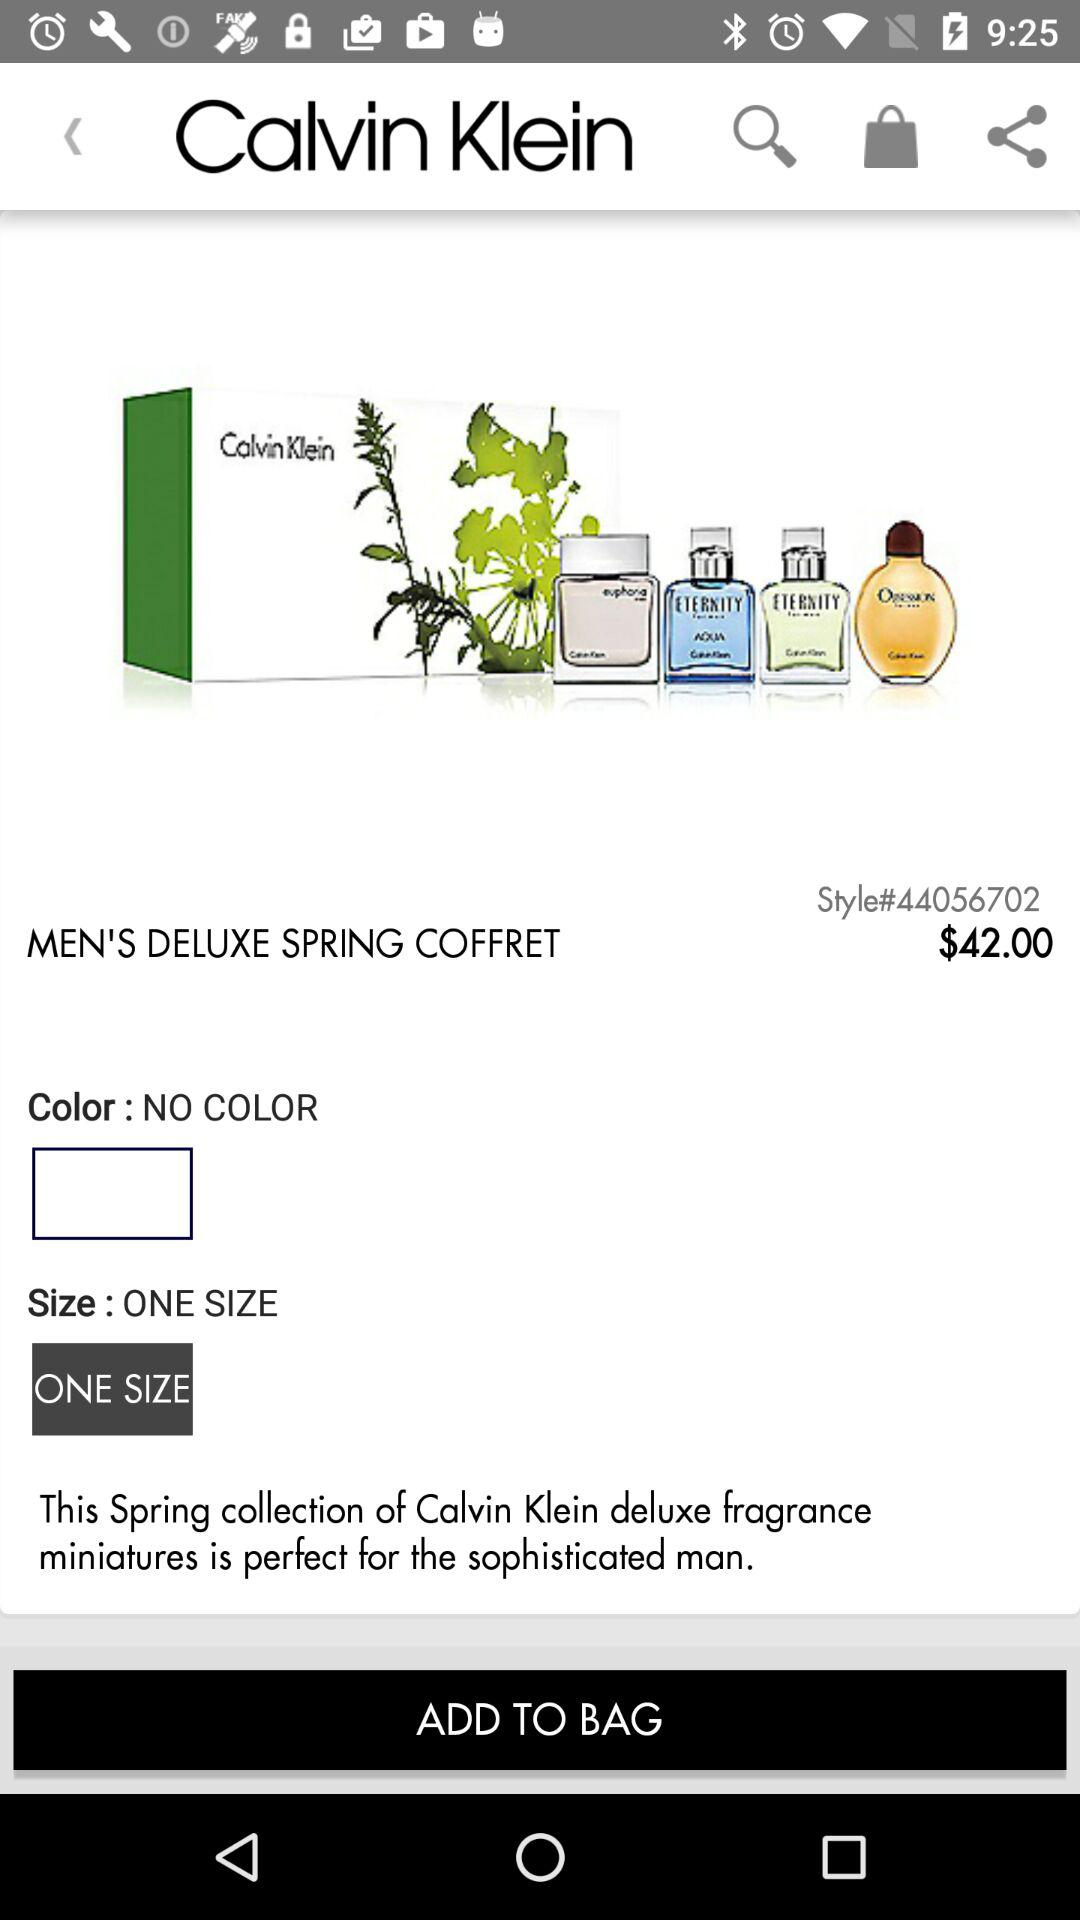Which color is shown on the screen? There is no color shown on the screen. 